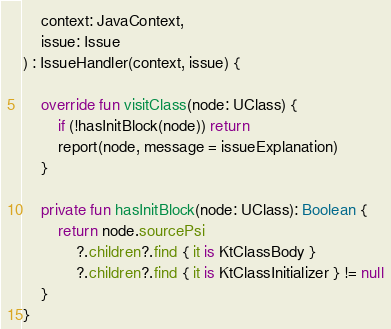Convert code to text. <code><loc_0><loc_0><loc_500><loc_500><_Kotlin_>    context: JavaContext,
    issue: Issue
) : IssueHandler(context, issue) {

    override fun visitClass(node: UClass) {
        if (!hasInitBlock(node)) return
        report(node, message = issueExplanation)
    }

    private fun hasInitBlock(node: UClass): Boolean {
        return node.sourcePsi
            ?.children?.find { it is KtClassBody }
            ?.children?.find { it is KtClassInitializer } != null
    }
}
</code> 